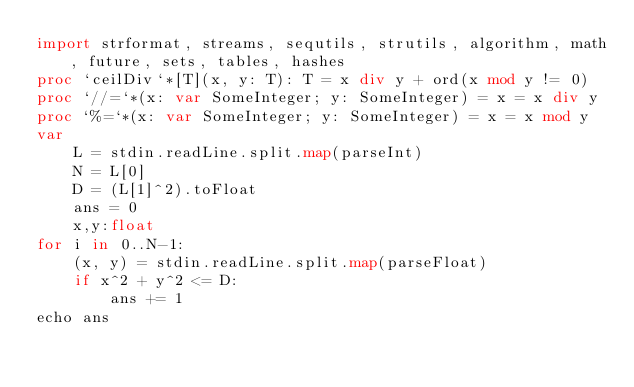Convert code to text. <code><loc_0><loc_0><loc_500><loc_500><_Nim_>import strformat, streams, sequtils, strutils, algorithm, math, future, sets, tables, hashes
proc `ceilDiv`*[T](x, y: T): T = x div y + ord(x mod y != 0)
proc `//=`*(x: var SomeInteger; y: SomeInteger) = x = x div y
proc `%=`*(x: var SomeInteger; y: SomeInteger) = x = x mod y
var
    L = stdin.readLine.split.map(parseInt)
    N = L[0]
    D = (L[1]^2).toFloat
    ans = 0
    x,y:float
for i in 0..N-1:
    (x, y) = stdin.readLine.split.map(parseFloat)
    if x^2 + y^2 <= D:
        ans += 1
echo ans</code> 